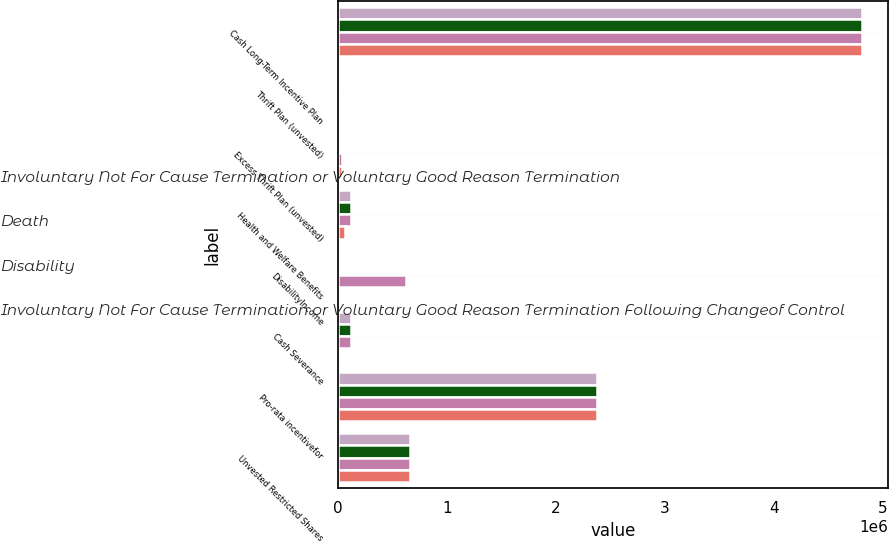<chart> <loc_0><loc_0><loc_500><loc_500><stacked_bar_chart><ecel><fcel>Cash Long-Term Incentive Plan<fcel>Thrift Plan (unvested)<fcel>Excess Thrift Plan (unvested)<fcel>Health and Welfare Benefits<fcel>DisabilityIncome<fcel>Cash Severance<fcel>Pro-rata incentivefor<fcel>Unvested Restricted Shares<nl><fcel>Involuntary Not For Cause Termination or Voluntary Good Reason Termination<fcel>4.80513e+06<fcel>0<fcel>0<fcel>120891<fcel>0<fcel>120891<fcel>2.375e+06<fcel>662705<nl><fcel>Death<fcel>4.80513e+06<fcel>0<fcel>0<fcel>120891<fcel>0<fcel>120891<fcel>2.375e+06<fcel>662705<nl><fcel>Disability<fcel>4.80513e+06<fcel>18180<fcel>33481<fcel>120891<fcel>623240<fcel>120891<fcel>2.375e+06<fcel>662705<nl><fcel>Involuntary Not For Cause Termination or Voluntary Good Reason Termination Following Changeof Control<fcel>4.80513e+06<fcel>18180<fcel>33481<fcel>60945<fcel>0<fcel>0<fcel>2.375e+06<fcel>662705<nl></chart> 